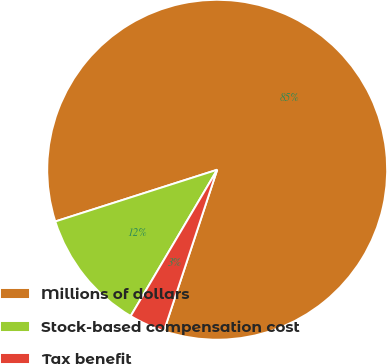Convert chart to OTSL. <chart><loc_0><loc_0><loc_500><loc_500><pie_chart><fcel>Millions of dollars<fcel>Stock-based compensation cost<fcel>Tax benefit<nl><fcel>85.0%<fcel>11.58%<fcel>3.42%<nl></chart> 